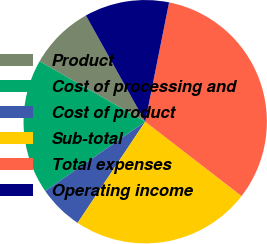<chart> <loc_0><loc_0><loc_500><loc_500><pie_chart><fcel>Product<fcel>Cost of processing and<fcel>Cost of product<fcel>Sub-total<fcel>Total expenses<fcel>Operating income<nl><fcel>8.62%<fcel>17.92%<fcel>5.98%<fcel>23.91%<fcel>32.32%<fcel>11.25%<nl></chart> 